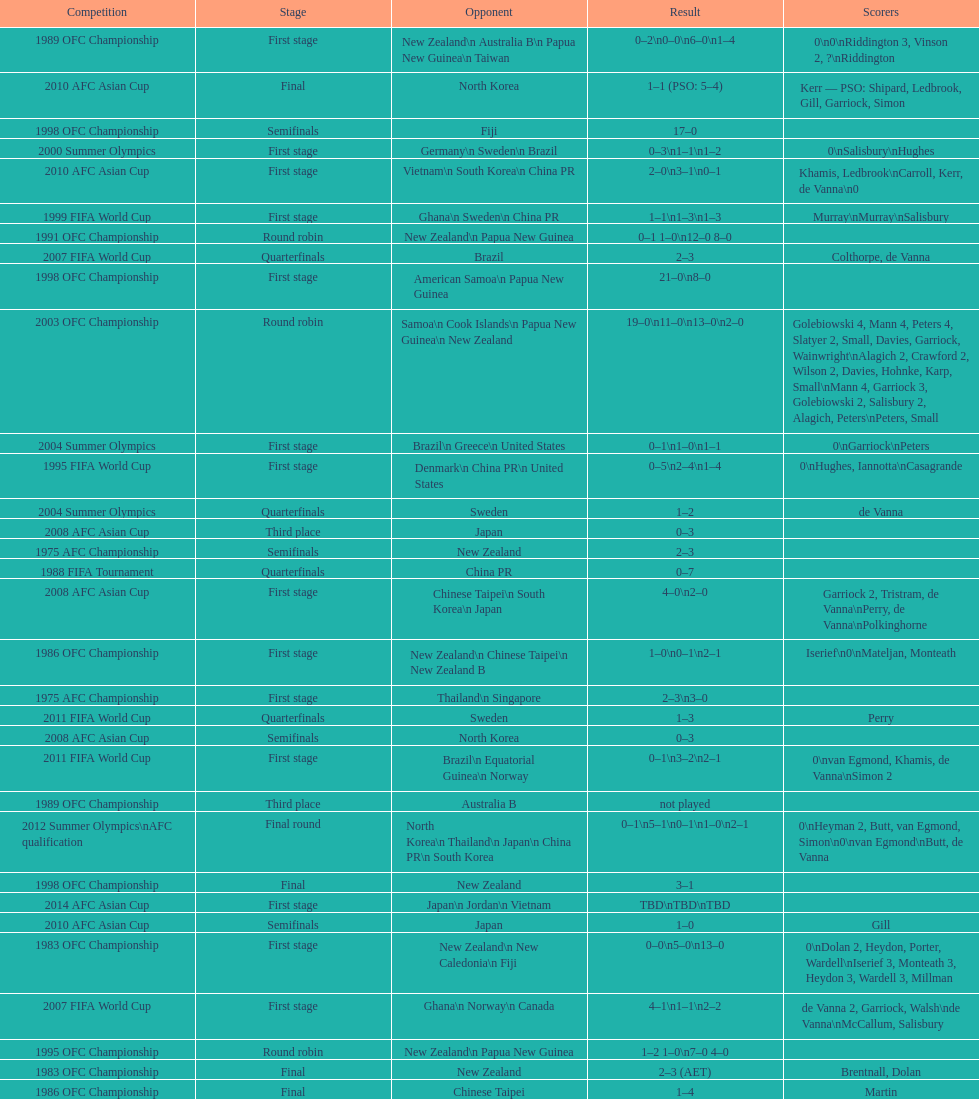What was the total goals made in the 1983 ofc championship? 18. 